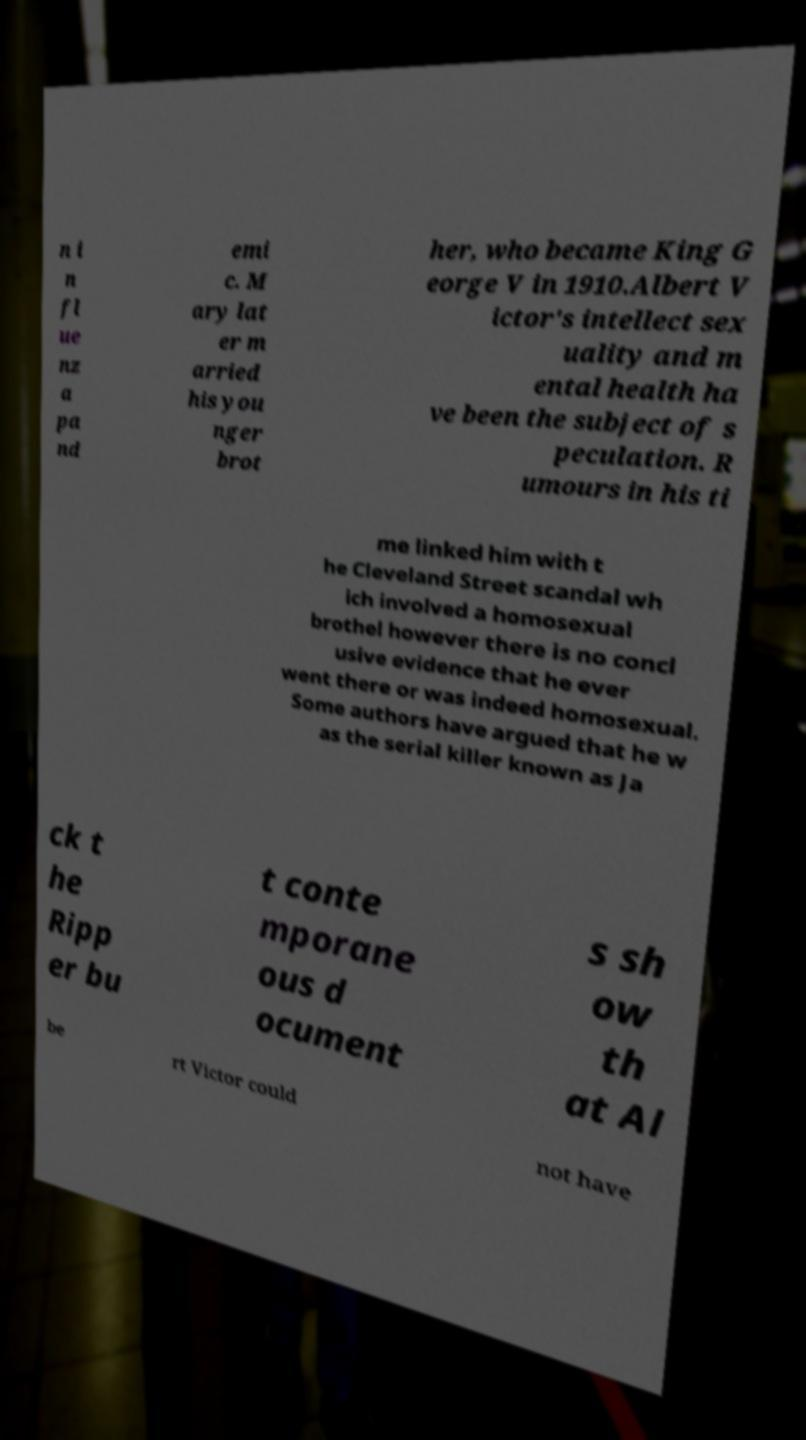Can you accurately transcribe the text from the provided image for me? n i n fl ue nz a pa nd emi c. M ary lat er m arried his you nger brot her, who became King G eorge V in 1910.Albert V ictor's intellect sex uality and m ental health ha ve been the subject of s peculation. R umours in his ti me linked him with t he Cleveland Street scandal wh ich involved a homosexual brothel however there is no concl usive evidence that he ever went there or was indeed homosexual. Some authors have argued that he w as the serial killer known as Ja ck t he Ripp er bu t conte mporane ous d ocument s sh ow th at Al be rt Victor could not have 